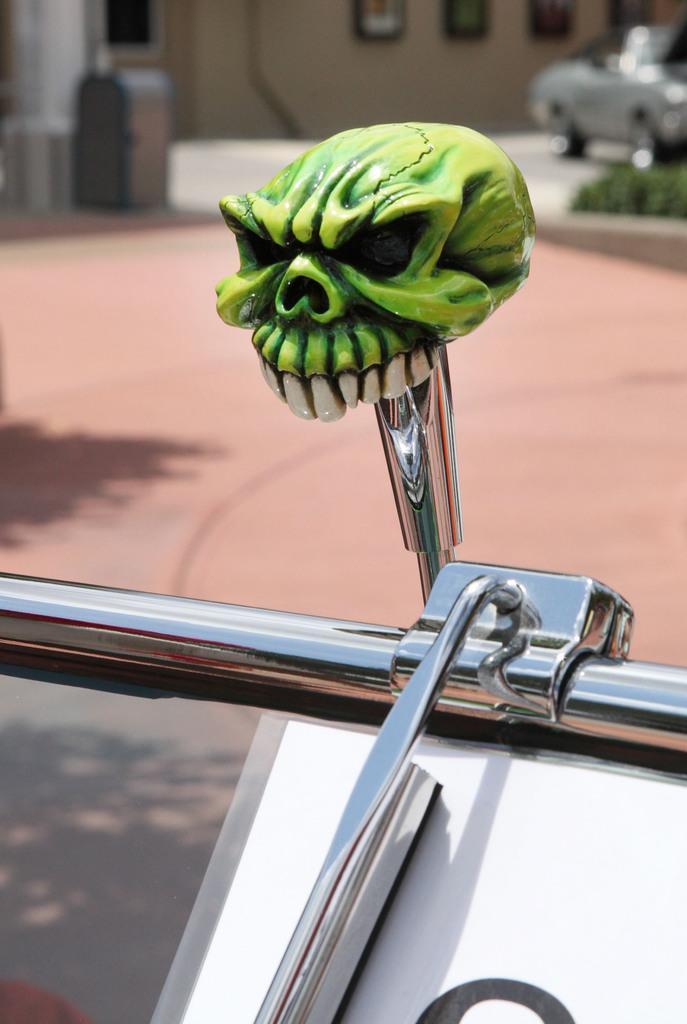Could you give a brief overview of what you see in this image? In this image I can see there is the green color skull toy on a stainless rod. At the top there is the car and a wall. 